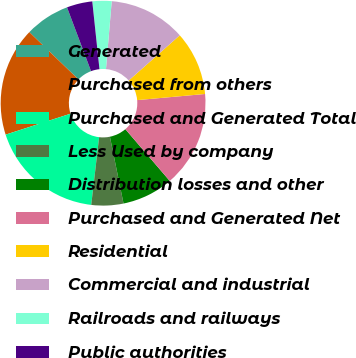Convert chart. <chart><loc_0><loc_0><loc_500><loc_500><pie_chart><fcel>Generated<fcel>Purchased from others<fcel>Purchased and Generated Total<fcel>Less Used by company<fcel>Distribution losses and other<fcel>Purchased and Generated Net<fcel>Residential<fcel>Commercial and industrial<fcel>Railroads and railways<fcel>Public authorities<nl><fcel>7.07%<fcel>17.17%<fcel>18.18%<fcel>5.05%<fcel>8.08%<fcel>15.15%<fcel>10.1%<fcel>12.12%<fcel>3.03%<fcel>4.04%<nl></chart> 